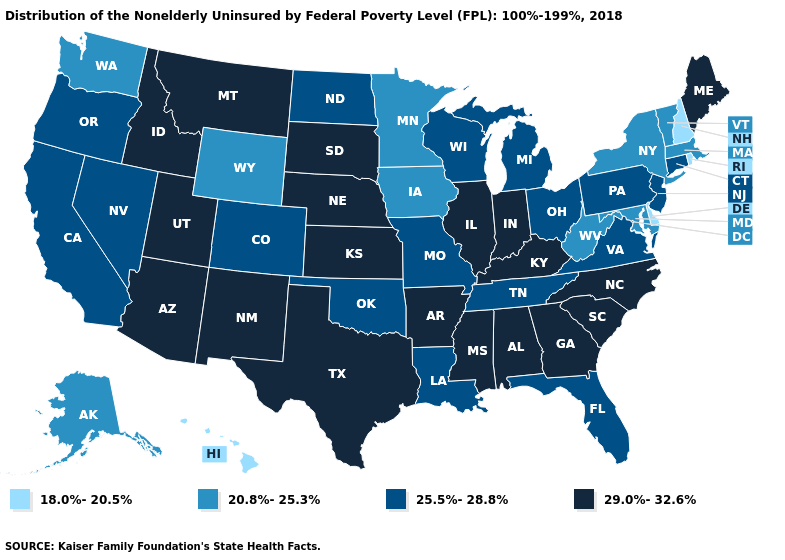Name the states that have a value in the range 18.0%-20.5%?
Quick response, please. Delaware, Hawaii, New Hampshire, Rhode Island. What is the lowest value in the Northeast?
Concise answer only. 18.0%-20.5%. Which states have the highest value in the USA?
Short answer required. Alabama, Arizona, Arkansas, Georgia, Idaho, Illinois, Indiana, Kansas, Kentucky, Maine, Mississippi, Montana, Nebraska, New Mexico, North Carolina, South Carolina, South Dakota, Texas, Utah. Name the states that have a value in the range 18.0%-20.5%?
Short answer required. Delaware, Hawaii, New Hampshire, Rhode Island. Does New Hampshire have the lowest value in the Northeast?
Keep it brief. Yes. What is the highest value in the Northeast ?
Write a very short answer. 29.0%-32.6%. Does Delaware have the lowest value in the South?
Give a very brief answer. Yes. Which states have the lowest value in the USA?
Concise answer only. Delaware, Hawaii, New Hampshire, Rhode Island. Name the states that have a value in the range 18.0%-20.5%?
Write a very short answer. Delaware, Hawaii, New Hampshire, Rhode Island. Does New Hampshire have a lower value than Rhode Island?
Concise answer only. No. What is the highest value in the South ?
Concise answer only. 29.0%-32.6%. What is the lowest value in the West?
Keep it brief. 18.0%-20.5%. What is the lowest value in states that border Massachusetts?
Write a very short answer. 18.0%-20.5%. Name the states that have a value in the range 18.0%-20.5%?
Be succinct. Delaware, Hawaii, New Hampshire, Rhode Island. Which states hav the highest value in the West?
Quick response, please. Arizona, Idaho, Montana, New Mexico, Utah. 